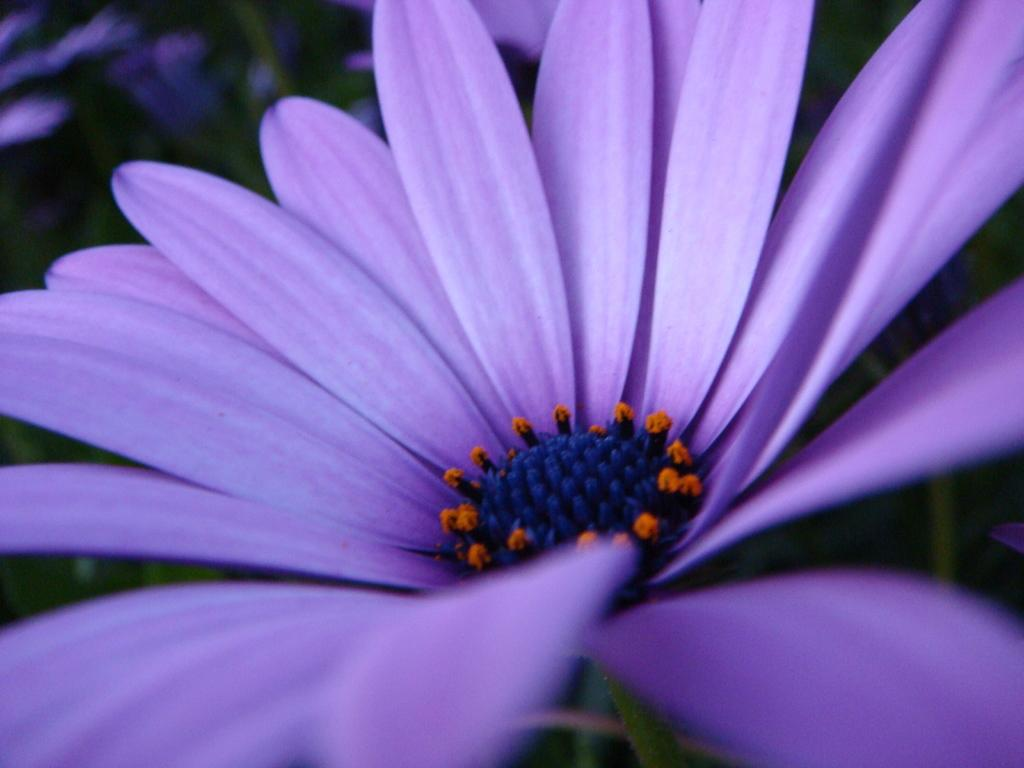What is the main subject of the image? There is a flower in the center of the image. Can you describe the surrounding elements in the image? There are other flowers in the background of the image. What type of string is used to tie the land together in the image? There is no land or string present in the image; it features flowers. 